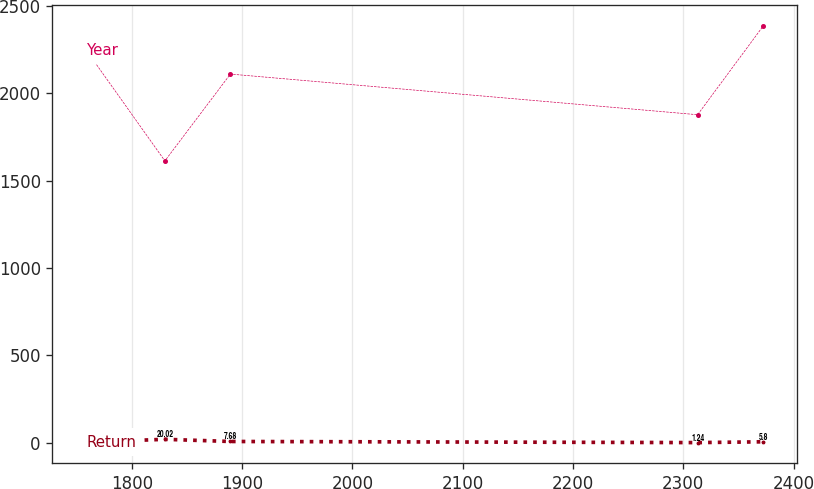Convert chart. <chart><loc_0><loc_0><loc_500><loc_500><line_chart><ecel><fcel>Return<fcel>Year<nl><fcel>1758.78<fcel>3.53<fcel>2245.48<nl><fcel>1830.03<fcel>20.02<fcel>1612.65<nl><fcel>1889.42<fcel>7.68<fcel>2109.25<nl><fcel>2312.99<fcel>1.24<fcel>1876.75<nl><fcel>2372.38<fcel>5.8<fcel>2383.52<nl></chart> 